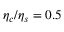Convert formula to latex. <formula><loc_0><loc_0><loc_500><loc_500>\eta _ { c } / \eta _ { s } = 0 . 5</formula> 